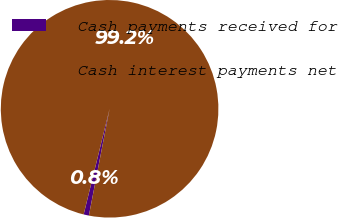Convert chart. <chart><loc_0><loc_0><loc_500><loc_500><pie_chart><fcel>Cash payments received for<fcel>Cash interest payments net<nl><fcel>0.78%<fcel>99.22%<nl></chart> 